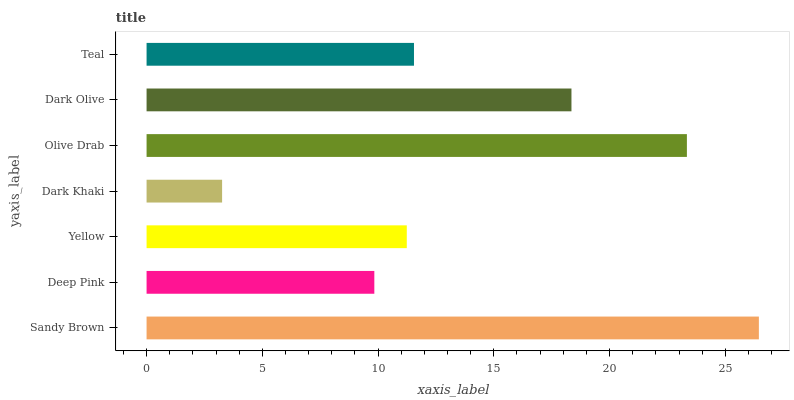Is Dark Khaki the minimum?
Answer yes or no. Yes. Is Sandy Brown the maximum?
Answer yes or no. Yes. Is Deep Pink the minimum?
Answer yes or no. No. Is Deep Pink the maximum?
Answer yes or no. No. Is Sandy Brown greater than Deep Pink?
Answer yes or no. Yes. Is Deep Pink less than Sandy Brown?
Answer yes or no. Yes. Is Deep Pink greater than Sandy Brown?
Answer yes or no. No. Is Sandy Brown less than Deep Pink?
Answer yes or no. No. Is Teal the high median?
Answer yes or no. Yes. Is Teal the low median?
Answer yes or no. Yes. Is Yellow the high median?
Answer yes or no. No. Is Deep Pink the low median?
Answer yes or no. No. 